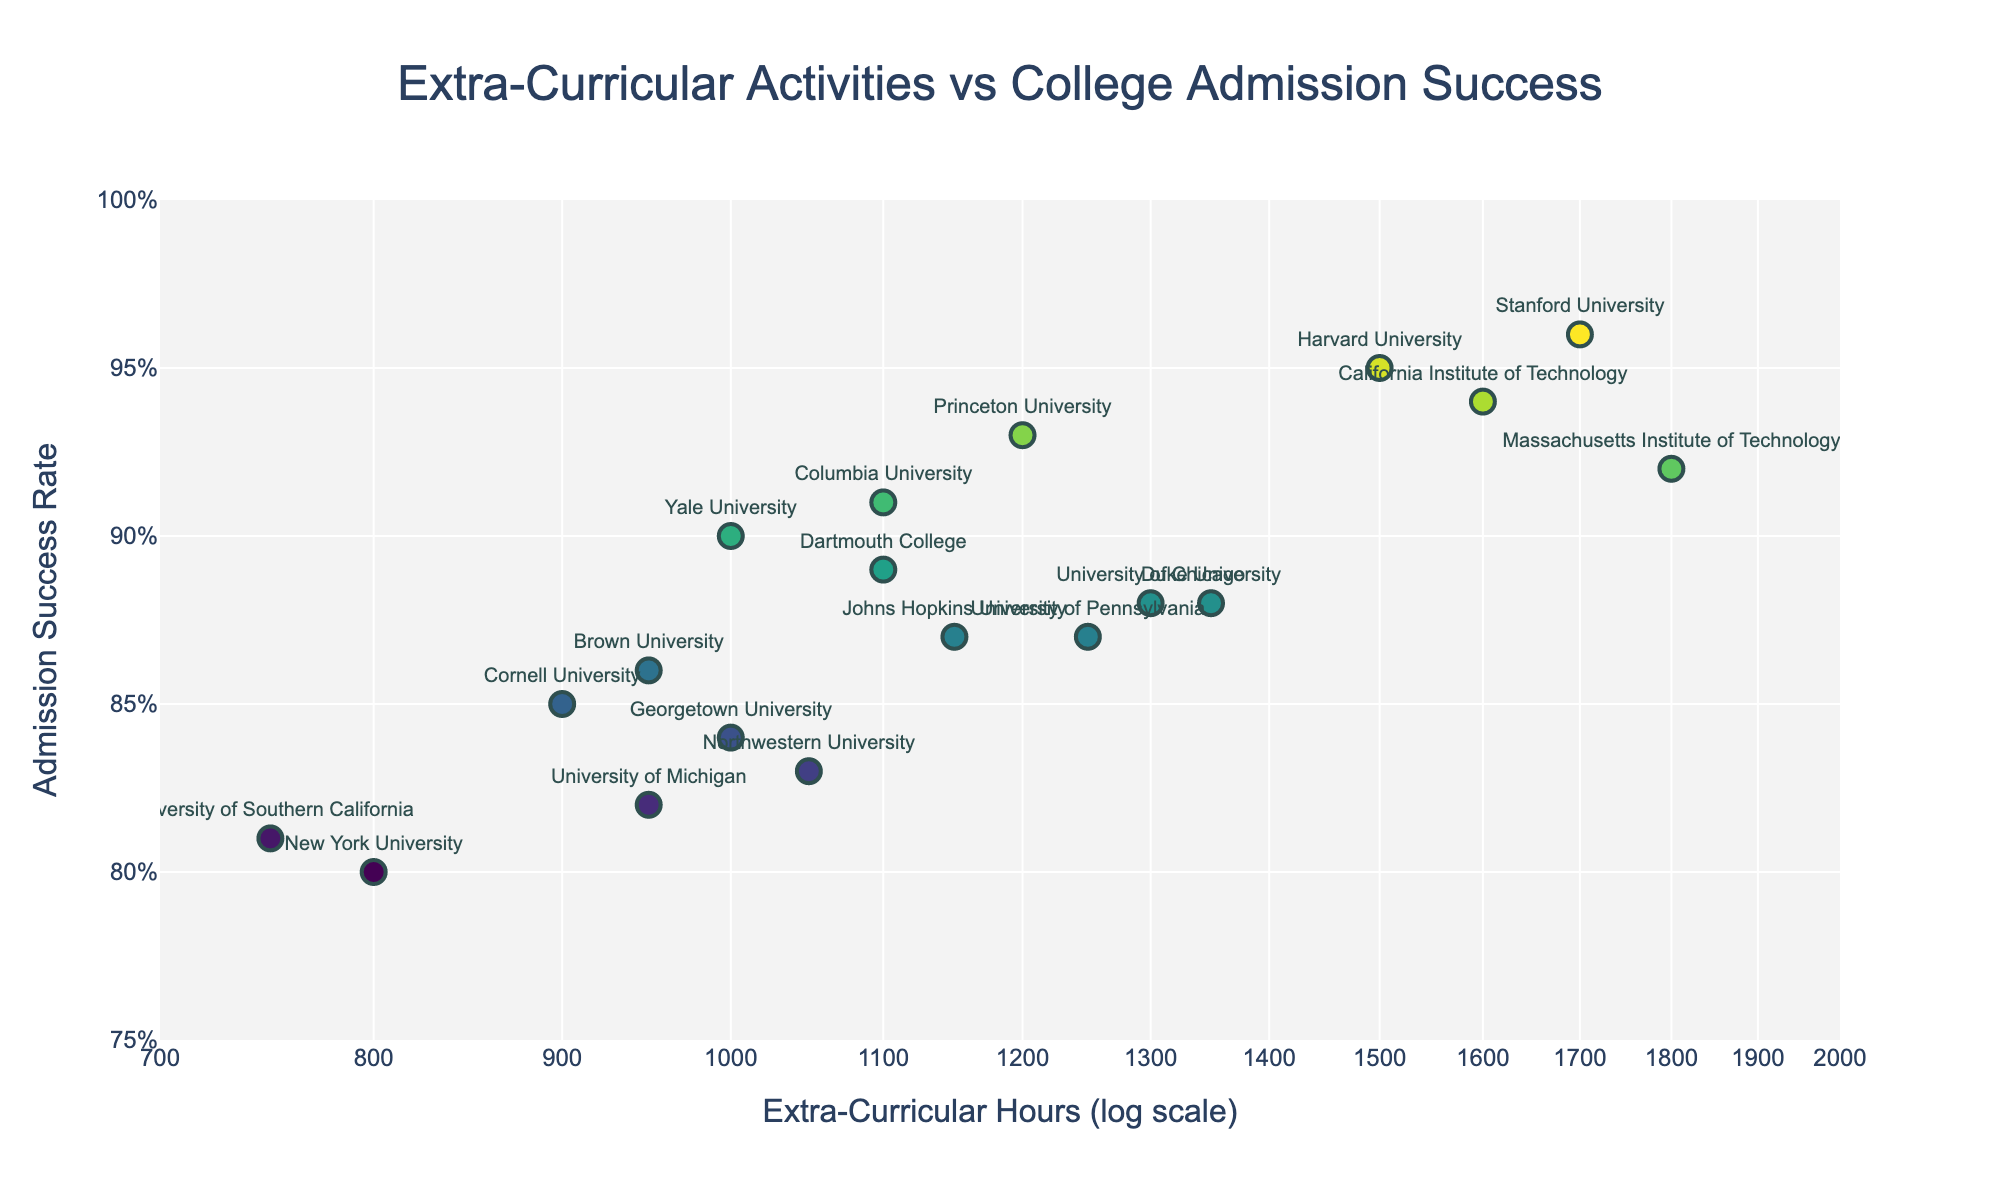what is the title of the scatter plot? the title is located at the top center of the figure and reads 'Extra-Curricular Activities vs College Admission Success', which summarizes the relationship being analyzed
Answer: Extra-Curricular Activities vs College Admission Success how many colleges are represented in the scatter plot? we count the number of data points or labels corresponding to different colleges in the scatter plot, which totals 19
Answer: 19 which college has the highest extra-curricular participation hours? by looking at the x-axis (log scale) and identifying the farthest right data point on the scatter plot, Stanford University has the highest extra-curricular participation hours at 1800
Answer: Stanford University what is the admission success rate of Georgetown University? we locate Georgetown University on the scatter plot by its label and information, where the corresponding y-axis value is approximately 0.84
Answer: 0.84 how many colleges have an admission success rate higher than 90%? by examining the y-axis and counting the data points above the 0.90 mark, we find that there are 6 colleges (Harvard, Stanford, MIT, Caltech, Princeton, Columbia)
Answer: 6 what is the difference in admission success rates between Cornell University and Brown University? we note Cornell's admission success rate (0.85) and Brown's (0.86) and subtract the two values: 0.86 - 0.85
Answer: 0.01 which college has the lowest admission success rate? examining the y-axis and identifying the lowest point on the plot, Northwestern University has the lowest admission success rate of 0.83
Answer: Northwestern University is there a general trend between extra-curricular participation hours and college admission success rates? the scatter plot indicates a positive relationship where colleges with higher extra-curricular participation hours tend to have higher admission success rates, depicted by data points clustering upwards as x values increase
Answer: Yes, positive trend how do Columbia University and University of Chicago compare in terms of extra-curricular participation hours and admission success rate? Columbia (1100 hours, 0.91 rate) has fewer extra-curricular hours but a higher admission success rate than the University of Chicago (1300 hours, 0.88 rate)
Answer: Columbia has fewer hours, higher rate what is the median extra-curricular participation hours for the colleges? first, we list the hours in ascending order: [750, 800, 900, 950, 950, 1000, 1000, 1050, 1100, 1100, 1150, 1200, 1250, 1300, 1350, 1500, 1600, 1700, 1800], the median value (10th value) is 1100
Answer: 1100 